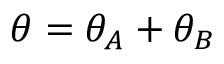<formula> <loc_0><loc_0><loc_500><loc_500>\theta = \theta _ { A } + \theta _ { B }</formula> 